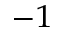Convert formula to latex. <formula><loc_0><loc_0><loc_500><loc_500>^ { - 1 }</formula> 